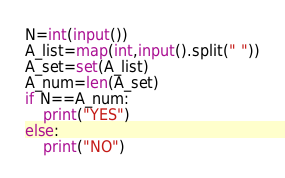<code> <loc_0><loc_0><loc_500><loc_500><_Python_>N=int(input())
A_list=map(int,input().split(" "))
A_set=set(A_list)
A_num=len(A_set)
if N==A_num:
    print("YES")
else:
    print("NO")</code> 